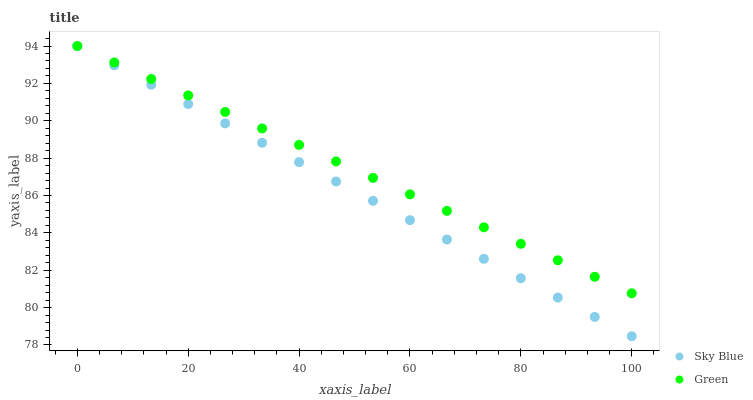Does Sky Blue have the minimum area under the curve?
Answer yes or no. Yes. Does Green have the maximum area under the curve?
Answer yes or no. Yes. Does Green have the minimum area under the curve?
Answer yes or no. No. Is Green the smoothest?
Answer yes or no. Yes. Is Sky Blue the roughest?
Answer yes or no. Yes. Is Green the roughest?
Answer yes or no. No. Does Sky Blue have the lowest value?
Answer yes or no. Yes. Does Green have the lowest value?
Answer yes or no. No. Does Green have the highest value?
Answer yes or no. Yes. Does Green intersect Sky Blue?
Answer yes or no. Yes. Is Green less than Sky Blue?
Answer yes or no. No. Is Green greater than Sky Blue?
Answer yes or no. No. 